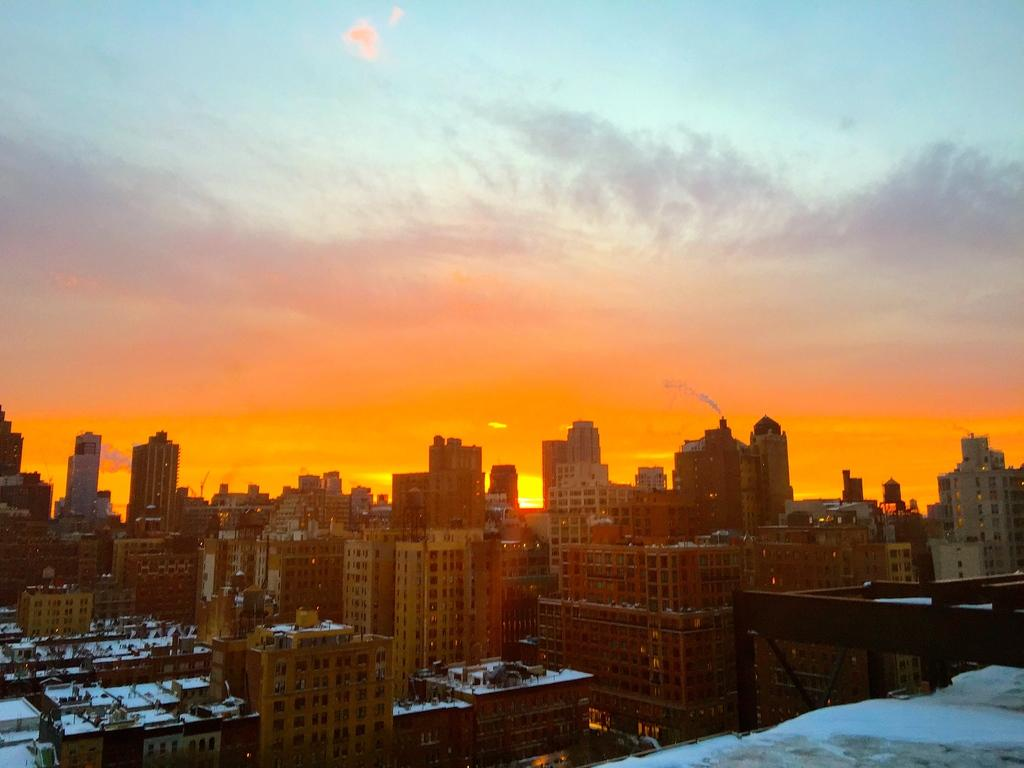What type of structures are visible in the image? There are many buildings with windows in the image. What can be seen in the background of the image? The sky is visible in the background of the image. What is the condition of the sky in the image? Clouds are present in the sky. Where is the hen located in the image? There is no hen present in the image. What type of hat is the church wearing in the image? There is no church or hat present in the image. 